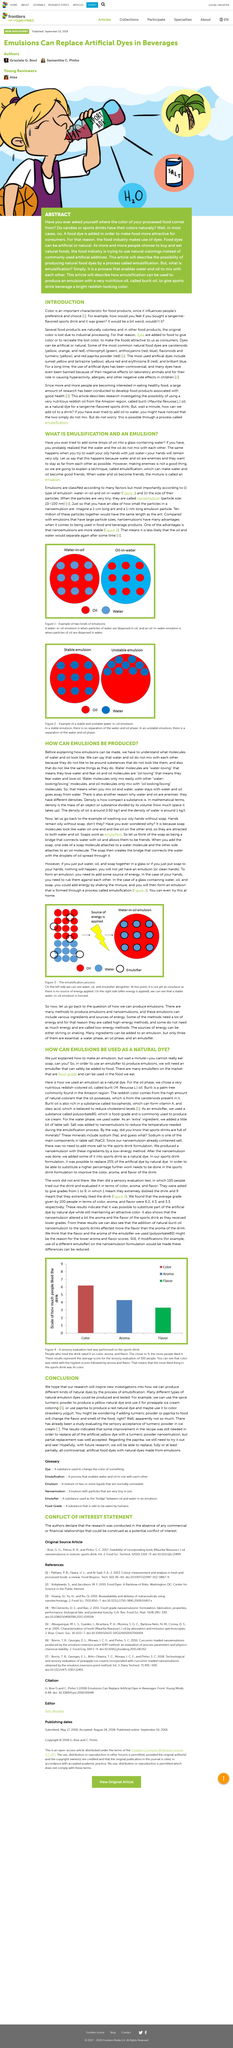Give some essential details in this illustration. An emulsion is the result of blending oil and water, resulting in a mixture that is stable and homogeneous. Emulsification is the process in which oil and water can be combined to form a stable mixture, enabling them to exist as one phase rather than two separate phases. Water and oil do not normally mix with each other. 